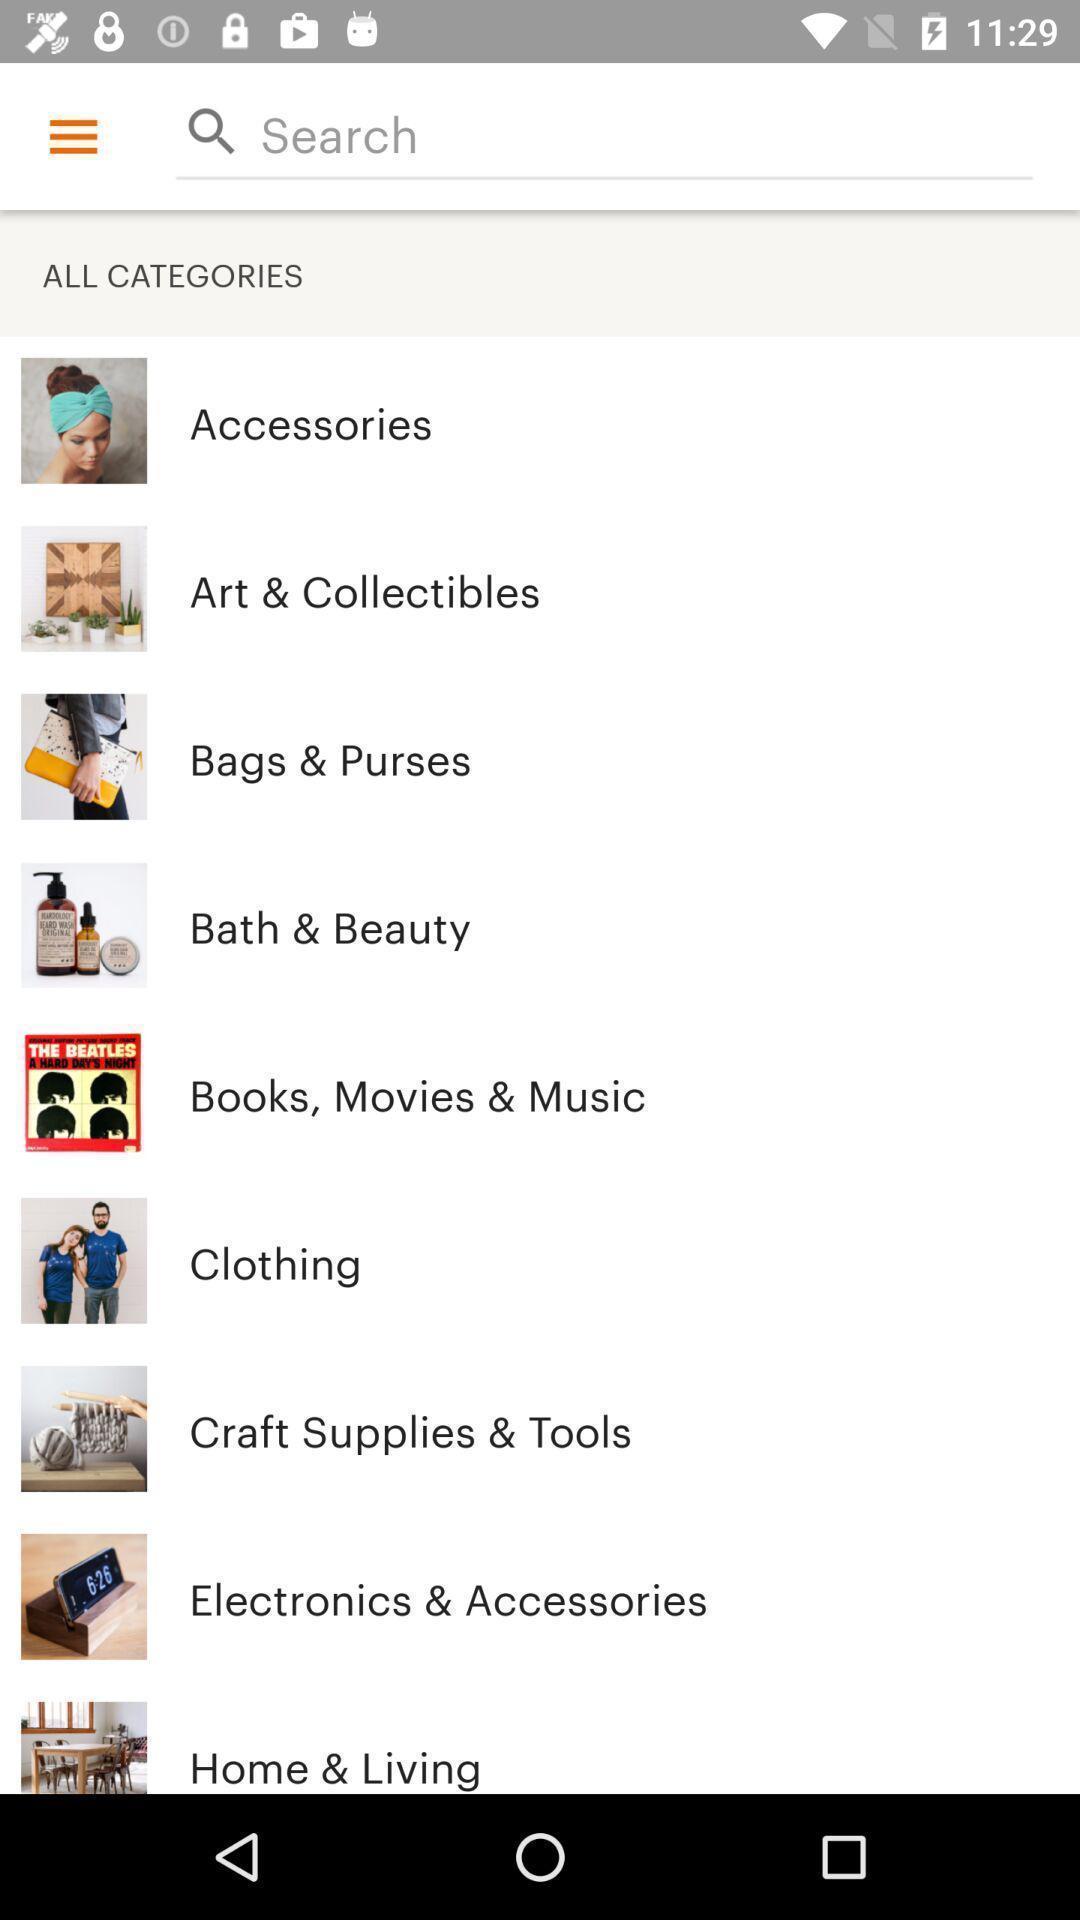Describe this image in words. Various categories of shopping items in app. 